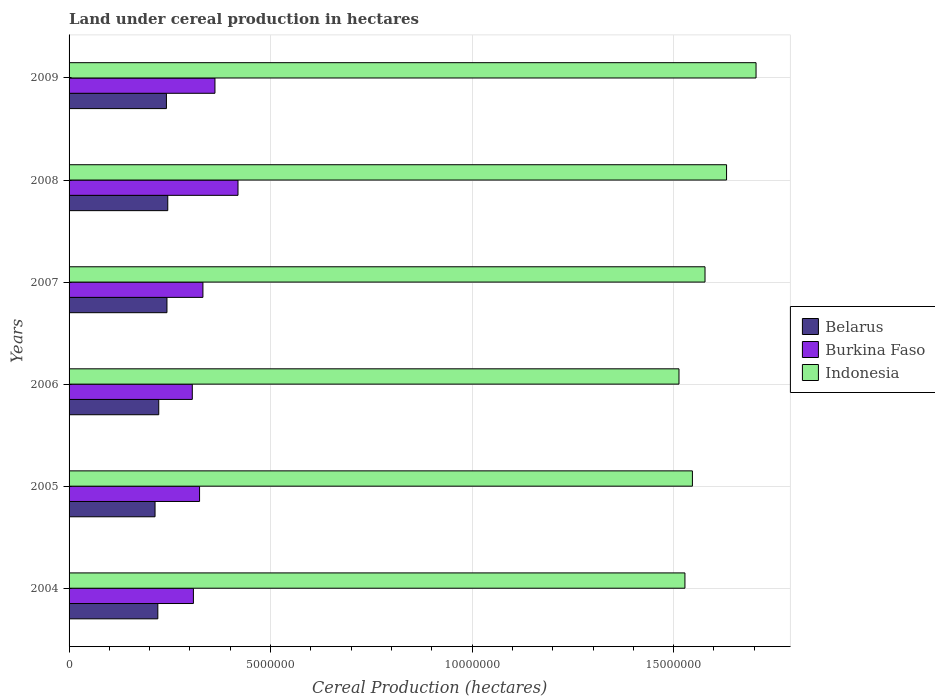How many different coloured bars are there?
Your response must be concise. 3. Are the number of bars per tick equal to the number of legend labels?
Provide a succinct answer. Yes. How many bars are there on the 2nd tick from the bottom?
Provide a succinct answer. 3. In how many cases, is the number of bars for a given year not equal to the number of legend labels?
Keep it short and to the point. 0. What is the land under cereal production in Indonesia in 2004?
Offer a terse response. 1.53e+07. Across all years, what is the maximum land under cereal production in Indonesia?
Offer a terse response. 1.70e+07. Across all years, what is the minimum land under cereal production in Indonesia?
Make the answer very short. 1.51e+07. In which year was the land under cereal production in Indonesia maximum?
Provide a succinct answer. 2009. In which year was the land under cereal production in Belarus minimum?
Offer a terse response. 2005. What is the total land under cereal production in Indonesia in the graph?
Make the answer very short. 9.50e+07. What is the difference between the land under cereal production in Burkina Faso in 2008 and that in 2009?
Provide a short and direct response. 5.72e+05. What is the difference between the land under cereal production in Indonesia in 2009 and the land under cereal production in Burkina Faso in 2007?
Provide a short and direct response. 1.37e+07. What is the average land under cereal production in Indonesia per year?
Keep it short and to the point. 1.58e+07. In the year 2005, what is the difference between the land under cereal production in Burkina Faso and land under cereal production in Indonesia?
Provide a short and direct response. -1.22e+07. In how many years, is the land under cereal production in Burkina Faso greater than 10000000 hectares?
Ensure brevity in your answer.  0. What is the ratio of the land under cereal production in Belarus in 2006 to that in 2007?
Give a very brief answer. 0.92. What is the difference between the highest and the second highest land under cereal production in Belarus?
Offer a very short reply. 2.01e+04. What is the difference between the highest and the lowest land under cereal production in Indonesia?
Your response must be concise. 1.91e+06. In how many years, is the land under cereal production in Indonesia greater than the average land under cereal production in Indonesia taken over all years?
Give a very brief answer. 2. Is the sum of the land under cereal production in Belarus in 2006 and 2007 greater than the maximum land under cereal production in Burkina Faso across all years?
Your answer should be very brief. Yes. What does the 2nd bar from the top in 2007 represents?
Keep it short and to the point. Burkina Faso. What does the 2nd bar from the bottom in 2005 represents?
Your answer should be compact. Burkina Faso. How many bars are there?
Provide a succinct answer. 18. Are the values on the major ticks of X-axis written in scientific E-notation?
Provide a succinct answer. No. Does the graph contain grids?
Provide a short and direct response. Yes. Where does the legend appear in the graph?
Your answer should be very brief. Center right. What is the title of the graph?
Give a very brief answer. Land under cereal production in hectares. What is the label or title of the X-axis?
Provide a succinct answer. Cereal Production (hectares). What is the label or title of the Y-axis?
Make the answer very short. Years. What is the Cereal Production (hectares) in Belarus in 2004?
Keep it short and to the point. 2.20e+06. What is the Cereal Production (hectares) in Burkina Faso in 2004?
Your answer should be very brief. 3.08e+06. What is the Cereal Production (hectares) of Indonesia in 2004?
Keep it short and to the point. 1.53e+07. What is the Cereal Production (hectares) in Belarus in 2005?
Offer a very short reply. 2.13e+06. What is the Cereal Production (hectares) in Burkina Faso in 2005?
Ensure brevity in your answer.  3.24e+06. What is the Cereal Production (hectares) in Indonesia in 2005?
Your response must be concise. 1.55e+07. What is the Cereal Production (hectares) in Belarus in 2006?
Provide a short and direct response. 2.22e+06. What is the Cereal Production (hectares) in Burkina Faso in 2006?
Ensure brevity in your answer.  3.06e+06. What is the Cereal Production (hectares) of Indonesia in 2006?
Your answer should be compact. 1.51e+07. What is the Cereal Production (hectares) of Belarus in 2007?
Your answer should be compact. 2.43e+06. What is the Cereal Production (hectares) in Burkina Faso in 2007?
Offer a terse response. 3.32e+06. What is the Cereal Production (hectares) in Indonesia in 2007?
Ensure brevity in your answer.  1.58e+07. What is the Cereal Production (hectares) in Belarus in 2008?
Give a very brief answer. 2.45e+06. What is the Cereal Production (hectares) of Burkina Faso in 2008?
Your response must be concise. 4.19e+06. What is the Cereal Production (hectares) in Indonesia in 2008?
Your answer should be compact. 1.63e+07. What is the Cereal Production (hectares) of Belarus in 2009?
Provide a short and direct response. 2.42e+06. What is the Cereal Production (hectares) of Burkina Faso in 2009?
Your response must be concise. 3.62e+06. What is the Cereal Production (hectares) in Indonesia in 2009?
Make the answer very short. 1.70e+07. Across all years, what is the maximum Cereal Production (hectares) of Belarus?
Offer a very short reply. 2.45e+06. Across all years, what is the maximum Cereal Production (hectares) in Burkina Faso?
Offer a very short reply. 4.19e+06. Across all years, what is the maximum Cereal Production (hectares) of Indonesia?
Your answer should be very brief. 1.70e+07. Across all years, what is the minimum Cereal Production (hectares) of Belarus?
Provide a succinct answer. 2.13e+06. Across all years, what is the minimum Cereal Production (hectares) in Burkina Faso?
Provide a succinct answer. 3.06e+06. Across all years, what is the minimum Cereal Production (hectares) of Indonesia?
Provide a succinct answer. 1.51e+07. What is the total Cereal Production (hectares) in Belarus in the graph?
Make the answer very short. 1.39e+07. What is the total Cereal Production (hectares) in Burkina Faso in the graph?
Keep it short and to the point. 2.05e+07. What is the total Cereal Production (hectares) of Indonesia in the graph?
Ensure brevity in your answer.  9.50e+07. What is the difference between the Cereal Production (hectares) in Belarus in 2004 and that in 2005?
Give a very brief answer. 6.90e+04. What is the difference between the Cereal Production (hectares) of Burkina Faso in 2004 and that in 2005?
Make the answer very short. -1.53e+05. What is the difference between the Cereal Production (hectares) in Indonesia in 2004 and that in 2005?
Offer a very short reply. -1.85e+05. What is the difference between the Cereal Production (hectares) of Belarus in 2004 and that in 2006?
Your response must be concise. -2.29e+04. What is the difference between the Cereal Production (hectares) in Burkina Faso in 2004 and that in 2006?
Offer a very short reply. 2.76e+04. What is the difference between the Cereal Production (hectares) of Indonesia in 2004 and that in 2006?
Your response must be concise. 1.48e+05. What is the difference between the Cereal Production (hectares) in Belarus in 2004 and that in 2007?
Keep it short and to the point. -2.27e+05. What is the difference between the Cereal Production (hectares) in Burkina Faso in 2004 and that in 2007?
Make the answer very short. -2.36e+05. What is the difference between the Cereal Production (hectares) of Indonesia in 2004 and that in 2007?
Offer a very short reply. -4.98e+05. What is the difference between the Cereal Production (hectares) in Belarus in 2004 and that in 2008?
Offer a terse response. -2.47e+05. What is the difference between the Cereal Production (hectares) in Burkina Faso in 2004 and that in 2008?
Your answer should be very brief. -1.11e+06. What is the difference between the Cereal Production (hectares) of Indonesia in 2004 and that in 2008?
Your answer should be very brief. -1.03e+06. What is the difference between the Cereal Production (hectares) of Belarus in 2004 and that in 2009?
Your answer should be very brief. -2.13e+05. What is the difference between the Cereal Production (hectares) of Burkina Faso in 2004 and that in 2009?
Make the answer very short. -5.34e+05. What is the difference between the Cereal Production (hectares) of Indonesia in 2004 and that in 2009?
Provide a succinct answer. -1.76e+06. What is the difference between the Cereal Production (hectares) of Belarus in 2005 and that in 2006?
Make the answer very short. -9.19e+04. What is the difference between the Cereal Production (hectares) of Burkina Faso in 2005 and that in 2006?
Provide a short and direct response. 1.80e+05. What is the difference between the Cereal Production (hectares) of Indonesia in 2005 and that in 2006?
Provide a succinct answer. 3.33e+05. What is the difference between the Cereal Production (hectares) of Belarus in 2005 and that in 2007?
Give a very brief answer. -2.96e+05. What is the difference between the Cereal Production (hectares) of Burkina Faso in 2005 and that in 2007?
Your response must be concise. -8.34e+04. What is the difference between the Cereal Production (hectares) of Indonesia in 2005 and that in 2007?
Ensure brevity in your answer.  -3.13e+05. What is the difference between the Cereal Production (hectares) in Belarus in 2005 and that in 2008?
Your response must be concise. -3.16e+05. What is the difference between the Cereal Production (hectares) of Burkina Faso in 2005 and that in 2008?
Your response must be concise. -9.54e+05. What is the difference between the Cereal Production (hectares) in Indonesia in 2005 and that in 2008?
Your answer should be very brief. -8.47e+05. What is the difference between the Cereal Production (hectares) in Belarus in 2005 and that in 2009?
Ensure brevity in your answer.  -2.83e+05. What is the difference between the Cereal Production (hectares) of Burkina Faso in 2005 and that in 2009?
Make the answer very short. -3.82e+05. What is the difference between the Cereal Production (hectares) of Indonesia in 2005 and that in 2009?
Your response must be concise. -1.58e+06. What is the difference between the Cereal Production (hectares) of Belarus in 2006 and that in 2007?
Ensure brevity in your answer.  -2.04e+05. What is the difference between the Cereal Production (hectares) in Burkina Faso in 2006 and that in 2007?
Provide a succinct answer. -2.64e+05. What is the difference between the Cereal Production (hectares) of Indonesia in 2006 and that in 2007?
Your answer should be very brief. -6.46e+05. What is the difference between the Cereal Production (hectares) in Belarus in 2006 and that in 2008?
Offer a very short reply. -2.24e+05. What is the difference between the Cereal Production (hectares) of Burkina Faso in 2006 and that in 2008?
Offer a very short reply. -1.13e+06. What is the difference between the Cereal Production (hectares) in Indonesia in 2006 and that in 2008?
Your response must be concise. -1.18e+06. What is the difference between the Cereal Production (hectares) of Belarus in 2006 and that in 2009?
Make the answer very short. -1.91e+05. What is the difference between the Cereal Production (hectares) in Burkina Faso in 2006 and that in 2009?
Your answer should be compact. -5.62e+05. What is the difference between the Cereal Production (hectares) of Indonesia in 2006 and that in 2009?
Keep it short and to the point. -1.91e+06. What is the difference between the Cereal Production (hectares) in Belarus in 2007 and that in 2008?
Offer a terse response. -2.01e+04. What is the difference between the Cereal Production (hectares) in Burkina Faso in 2007 and that in 2008?
Your response must be concise. -8.70e+05. What is the difference between the Cereal Production (hectares) in Indonesia in 2007 and that in 2008?
Offer a very short reply. -5.35e+05. What is the difference between the Cereal Production (hectares) in Belarus in 2007 and that in 2009?
Keep it short and to the point. 1.32e+04. What is the difference between the Cereal Production (hectares) in Burkina Faso in 2007 and that in 2009?
Your answer should be very brief. -2.98e+05. What is the difference between the Cereal Production (hectares) of Indonesia in 2007 and that in 2009?
Offer a very short reply. -1.27e+06. What is the difference between the Cereal Production (hectares) of Belarus in 2008 and that in 2009?
Your answer should be very brief. 3.33e+04. What is the difference between the Cereal Production (hectares) of Burkina Faso in 2008 and that in 2009?
Make the answer very short. 5.72e+05. What is the difference between the Cereal Production (hectares) in Indonesia in 2008 and that in 2009?
Ensure brevity in your answer.  -7.32e+05. What is the difference between the Cereal Production (hectares) of Belarus in 2004 and the Cereal Production (hectares) of Burkina Faso in 2005?
Ensure brevity in your answer.  -1.04e+06. What is the difference between the Cereal Production (hectares) in Belarus in 2004 and the Cereal Production (hectares) in Indonesia in 2005?
Offer a terse response. -1.33e+07. What is the difference between the Cereal Production (hectares) of Burkina Faso in 2004 and the Cereal Production (hectares) of Indonesia in 2005?
Offer a very short reply. -1.24e+07. What is the difference between the Cereal Production (hectares) of Belarus in 2004 and the Cereal Production (hectares) of Burkina Faso in 2006?
Your response must be concise. -8.55e+05. What is the difference between the Cereal Production (hectares) of Belarus in 2004 and the Cereal Production (hectares) of Indonesia in 2006?
Keep it short and to the point. -1.29e+07. What is the difference between the Cereal Production (hectares) in Burkina Faso in 2004 and the Cereal Production (hectares) in Indonesia in 2006?
Offer a very short reply. -1.20e+07. What is the difference between the Cereal Production (hectares) in Belarus in 2004 and the Cereal Production (hectares) in Burkina Faso in 2007?
Your response must be concise. -1.12e+06. What is the difference between the Cereal Production (hectares) of Belarus in 2004 and the Cereal Production (hectares) of Indonesia in 2007?
Your response must be concise. -1.36e+07. What is the difference between the Cereal Production (hectares) in Burkina Faso in 2004 and the Cereal Production (hectares) in Indonesia in 2007?
Give a very brief answer. -1.27e+07. What is the difference between the Cereal Production (hectares) in Belarus in 2004 and the Cereal Production (hectares) in Burkina Faso in 2008?
Offer a terse response. -1.99e+06. What is the difference between the Cereal Production (hectares) of Belarus in 2004 and the Cereal Production (hectares) of Indonesia in 2008?
Give a very brief answer. -1.41e+07. What is the difference between the Cereal Production (hectares) of Burkina Faso in 2004 and the Cereal Production (hectares) of Indonesia in 2008?
Your answer should be very brief. -1.32e+07. What is the difference between the Cereal Production (hectares) in Belarus in 2004 and the Cereal Production (hectares) in Burkina Faso in 2009?
Provide a succinct answer. -1.42e+06. What is the difference between the Cereal Production (hectares) of Belarus in 2004 and the Cereal Production (hectares) of Indonesia in 2009?
Your response must be concise. -1.48e+07. What is the difference between the Cereal Production (hectares) in Burkina Faso in 2004 and the Cereal Production (hectares) in Indonesia in 2009?
Offer a very short reply. -1.40e+07. What is the difference between the Cereal Production (hectares) of Belarus in 2005 and the Cereal Production (hectares) of Burkina Faso in 2006?
Make the answer very short. -9.24e+05. What is the difference between the Cereal Production (hectares) of Belarus in 2005 and the Cereal Production (hectares) of Indonesia in 2006?
Ensure brevity in your answer.  -1.30e+07. What is the difference between the Cereal Production (hectares) of Burkina Faso in 2005 and the Cereal Production (hectares) of Indonesia in 2006?
Make the answer very short. -1.19e+07. What is the difference between the Cereal Production (hectares) in Belarus in 2005 and the Cereal Production (hectares) in Burkina Faso in 2007?
Make the answer very short. -1.19e+06. What is the difference between the Cereal Production (hectares) of Belarus in 2005 and the Cereal Production (hectares) of Indonesia in 2007?
Keep it short and to the point. -1.36e+07. What is the difference between the Cereal Production (hectares) in Burkina Faso in 2005 and the Cereal Production (hectares) in Indonesia in 2007?
Your answer should be very brief. -1.25e+07. What is the difference between the Cereal Production (hectares) of Belarus in 2005 and the Cereal Production (hectares) of Burkina Faso in 2008?
Your answer should be compact. -2.06e+06. What is the difference between the Cereal Production (hectares) in Belarus in 2005 and the Cereal Production (hectares) in Indonesia in 2008?
Provide a succinct answer. -1.42e+07. What is the difference between the Cereal Production (hectares) of Burkina Faso in 2005 and the Cereal Production (hectares) of Indonesia in 2008?
Keep it short and to the point. -1.31e+07. What is the difference between the Cereal Production (hectares) in Belarus in 2005 and the Cereal Production (hectares) in Burkina Faso in 2009?
Your answer should be very brief. -1.49e+06. What is the difference between the Cereal Production (hectares) in Belarus in 2005 and the Cereal Production (hectares) in Indonesia in 2009?
Offer a terse response. -1.49e+07. What is the difference between the Cereal Production (hectares) in Burkina Faso in 2005 and the Cereal Production (hectares) in Indonesia in 2009?
Offer a very short reply. -1.38e+07. What is the difference between the Cereal Production (hectares) of Belarus in 2006 and the Cereal Production (hectares) of Burkina Faso in 2007?
Offer a terse response. -1.10e+06. What is the difference between the Cereal Production (hectares) in Belarus in 2006 and the Cereal Production (hectares) in Indonesia in 2007?
Your answer should be very brief. -1.36e+07. What is the difference between the Cereal Production (hectares) in Burkina Faso in 2006 and the Cereal Production (hectares) in Indonesia in 2007?
Ensure brevity in your answer.  -1.27e+07. What is the difference between the Cereal Production (hectares) in Belarus in 2006 and the Cereal Production (hectares) in Burkina Faso in 2008?
Keep it short and to the point. -1.97e+06. What is the difference between the Cereal Production (hectares) in Belarus in 2006 and the Cereal Production (hectares) in Indonesia in 2008?
Offer a very short reply. -1.41e+07. What is the difference between the Cereal Production (hectares) in Burkina Faso in 2006 and the Cereal Production (hectares) in Indonesia in 2008?
Provide a short and direct response. -1.33e+07. What is the difference between the Cereal Production (hectares) in Belarus in 2006 and the Cereal Production (hectares) in Burkina Faso in 2009?
Offer a terse response. -1.39e+06. What is the difference between the Cereal Production (hectares) in Belarus in 2006 and the Cereal Production (hectares) in Indonesia in 2009?
Provide a succinct answer. -1.48e+07. What is the difference between the Cereal Production (hectares) of Burkina Faso in 2006 and the Cereal Production (hectares) of Indonesia in 2009?
Ensure brevity in your answer.  -1.40e+07. What is the difference between the Cereal Production (hectares) in Belarus in 2007 and the Cereal Production (hectares) in Burkina Faso in 2008?
Offer a terse response. -1.76e+06. What is the difference between the Cereal Production (hectares) of Belarus in 2007 and the Cereal Production (hectares) of Indonesia in 2008?
Ensure brevity in your answer.  -1.39e+07. What is the difference between the Cereal Production (hectares) in Burkina Faso in 2007 and the Cereal Production (hectares) in Indonesia in 2008?
Your answer should be very brief. -1.30e+07. What is the difference between the Cereal Production (hectares) of Belarus in 2007 and the Cereal Production (hectares) of Burkina Faso in 2009?
Provide a succinct answer. -1.19e+06. What is the difference between the Cereal Production (hectares) in Belarus in 2007 and the Cereal Production (hectares) in Indonesia in 2009?
Provide a short and direct response. -1.46e+07. What is the difference between the Cereal Production (hectares) of Burkina Faso in 2007 and the Cereal Production (hectares) of Indonesia in 2009?
Offer a very short reply. -1.37e+07. What is the difference between the Cereal Production (hectares) in Belarus in 2008 and the Cereal Production (hectares) in Burkina Faso in 2009?
Offer a very short reply. -1.17e+06. What is the difference between the Cereal Production (hectares) in Belarus in 2008 and the Cereal Production (hectares) in Indonesia in 2009?
Give a very brief answer. -1.46e+07. What is the difference between the Cereal Production (hectares) of Burkina Faso in 2008 and the Cereal Production (hectares) of Indonesia in 2009?
Your response must be concise. -1.29e+07. What is the average Cereal Production (hectares) in Belarus per year?
Keep it short and to the point. 2.31e+06. What is the average Cereal Production (hectares) of Burkina Faso per year?
Provide a short and direct response. 3.42e+06. What is the average Cereal Production (hectares) in Indonesia per year?
Ensure brevity in your answer.  1.58e+07. In the year 2004, what is the difference between the Cereal Production (hectares) in Belarus and Cereal Production (hectares) in Burkina Faso?
Offer a terse response. -8.83e+05. In the year 2004, what is the difference between the Cereal Production (hectares) of Belarus and Cereal Production (hectares) of Indonesia?
Ensure brevity in your answer.  -1.31e+07. In the year 2004, what is the difference between the Cereal Production (hectares) in Burkina Faso and Cereal Production (hectares) in Indonesia?
Keep it short and to the point. -1.22e+07. In the year 2005, what is the difference between the Cereal Production (hectares) in Belarus and Cereal Production (hectares) in Burkina Faso?
Your answer should be compact. -1.10e+06. In the year 2005, what is the difference between the Cereal Production (hectares) of Belarus and Cereal Production (hectares) of Indonesia?
Offer a terse response. -1.33e+07. In the year 2005, what is the difference between the Cereal Production (hectares) of Burkina Faso and Cereal Production (hectares) of Indonesia?
Ensure brevity in your answer.  -1.22e+07. In the year 2006, what is the difference between the Cereal Production (hectares) of Belarus and Cereal Production (hectares) of Burkina Faso?
Your answer should be compact. -8.32e+05. In the year 2006, what is the difference between the Cereal Production (hectares) in Belarus and Cereal Production (hectares) in Indonesia?
Offer a very short reply. -1.29e+07. In the year 2006, what is the difference between the Cereal Production (hectares) of Burkina Faso and Cereal Production (hectares) of Indonesia?
Provide a succinct answer. -1.21e+07. In the year 2007, what is the difference between the Cereal Production (hectares) of Belarus and Cereal Production (hectares) of Burkina Faso?
Your answer should be very brief. -8.92e+05. In the year 2007, what is the difference between the Cereal Production (hectares) in Belarus and Cereal Production (hectares) in Indonesia?
Keep it short and to the point. -1.33e+07. In the year 2007, what is the difference between the Cereal Production (hectares) of Burkina Faso and Cereal Production (hectares) of Indonesia?
Your answer should be very brief. -1.25e+07. In the year 2008, what is the difference between the Cereal Production (hectares) in Belarus and Cereal Production (hectares) in Burkina Faso?
Your answer should be very brief. -1.74e+06. In the year 2008, what is the difference between the Cereal Production (hectares) in Belarus and Cereal Production (hectares) in Indonesia?
Offer a terse response. -1.39e+07. In the year 2008, what is the difference between the Cereal Production (hectares) in Burkina Faso and Cereal Production (hectares) in Indonesia?
Ensure brevity in your answer.  -1.21e+07. In the year 2009, what is the difference between the Cereal Production (hectares) of Belarus and Cereal Production (hectares) of Burkina Faso?
Ensure brevity in your answer.  -1.20e+06. In the year 2009, what is the difference between the Cereal Production (hectares) in Belarus and Cereal Production (hectares) in Indonesia?
Keep it short and to the point. -1.46e+07. In the year 2009, what is the difference between the Cereal Production (hectares) of Burkina Faso and Cereal Production (hectares) of Indonesia?
Your answer should be very brief. -1.34e+07. What is the ratio of the Cereal Production (hectares) in Belarus in 2004 to that in 2005?
Provide a succinct answer. 1.03. What is the ratio of the Cereal Production (hectares) of Burkina Faso in 2004 to that in 2005?
Make the answer very short. 0.95. What is the ratio of the Cereal Production (hectares) in Indonesia in 2004 to that in 2005?
Give a very brief answer. 0.99. What is the ratio of the Cereal Production (hectares) in Belarus in 2004 to that in 2006?
Provide a short and direct response. 0.99. What is the ratio of the Cereal Production (hectares) in Indonesia in 2004 to that in 2006?
Offer a very short reply. 1.01. What is the ratio of the Cereal Production (hectares) in Belarus in 2004 to that in 2007?
Offer a terse response. 0.91. What is the ratio of the Cereal Production (hectares) in Burkina Faso in 2004 to that in 2007?
Your answer should be very brief. 0.93. What is the ratio of the Cereal Production (hectares) in Indonesia in 2004 to that in 2007?
Provide a short and direct response. 0.97. What is the ratio of the Cereal Production (hectares) of Belarus in 2004 to that in 2008?
Your answer should be compact. 0.9. What is the ratio of the Cereal Production (hectares) of Burkina Faso in 2004 to that in 2008?
Ensure brevity in your answer.  0.74. What is the ratio of the Cereal Production (hectares) of Indonesia in 2004 to that in 2008?
Provide a succinct answer. 0.94. What is the ratio of the Cereal Production (hectares) in Belarus in 2004 to that in 2009?
Provide a short and direct response. 0.91. What is the ratio of the Cereal Production (hectares) in Burkina Faso in 2004 to that in 2009?
Your response must be concise. 0.85. What is the ratio of the Cereal Production (hectares) in Indonesia in 2004 to that in 2009?
Your response must be concise. 0.9. What is the ratio of the Cereal Production (hectares) of Belarus in 2005 to that in 2006?
Give a very brief answer. 0.96. What is the ratio of the Cereal Production (hectares) of Burkina Faso in 2005 to that in 2006?
Provide a short and direct response. 1.06. What is the ratio of the Cereal Production (hectares) of Belarus in 2005 to that in 2007?
Keep it short and to the point. 0.88. What is the ratio of the Cereal Production (hectares) of Burkina Faso in 2005 to that in 2007?
Offer a terse response. 0.97. What is the ratio of the Cereal Production (hectares) of Indonesia in 2005 to that in 2007?
Give a very brief answer. 0.98. What is the ratio of the Cereal Production (hectares) of Belarus in 2005 to that in 2008?
Ensure brevity in your answer.  0.87. What is the ratio of the Cereal Production (hectares) in Burkina Faso in 2005 to that in 2008?
Offer a very short reply. 0.77. What is the ratio of the Cereal Production (hectares) in Indonesia in 2005 to that in 2008?
Offer a very short reply. 0.95. What is the ratio of the Cereal Production (hectares) in Belarus in 2005 to that in 2009?
Your response must be concise. 0.88. What is the ratio of the Cereal Production (hectares) of Burkina Faso in 2005 to that in 2009?
Offer a very short reply. 0.89. What is the ratio of the Cereal Production (hectares) in Indonesia in 2005 to that in 2009?
Offer a terse response. 0.91. What is the ratio of the Cereal Production (hectares) in Belarus in 2006 to that in 2007?
Offer a very short reply. 0.92. What is the ratio of the Cereal Production (hectares) of Burkina Faso in 2006 to that in 2007?
Provide a succinct answer. 0.92. What is the ratio of the Cereal Production (hectares) of Indonesia in 2006 to that in 2007?
Provide a succinct answer. 0.96. What is the ratio of the Cereal Production (hectares) of Belarus in 2006 to that in 2008?
Make the answer very short. 0.91. What is the ratio of the Cereal Production (hectares) in Burkina Faso in 2006 to that in 2008?
Offer a terse response. 0.73. What is the ratio of the Cereal Production (hectares) of Indonesia in 2006 to that in 2008?
Provide a succinct answer. 0.93. What is the ratio of the Cereal Production (hectares) in Belarus in 2006 to that in 2009?
Provide a succinct answer. 0.92. What is the ratio of the Cereal Production (hectares) of Burkina Faso in 2006 to that in 2009?
Your answer should be very brief. 0.84. What is the ratio of the Cereal Production (hectares) in Indonesia in 2006 to that in 2009?
Make the answer very short. 0.89. What is the ratio of the Cereal Production (hectares) in Burkina Faso in 2007 to that in 2008?
Make the answer very short. 0.79. What is the ratio of the Cereal Production (hectares) in Indonesia in 2007 to that in 2008?
Your response must be concise. 0.97. What is the ratio of the Cereal Production (hectares) of Belarus in 2007 to that in 2009?
Provide a succinct answer. 1.01. What is the ratio of the Cereal Production (hectares) in Burkina Faso in 2007 to that in 2009?
Your answer should be very brief. 0.92. What is the ratio of the Cereal Production (hectares) in Indonesia in 2007 to that in 2009?
Keep it short and to the point. 0.93. What is the ratio of the Cereal Production (hectares) of Belarus in 2008 to that in 2009?
Ensure brevity in your answer.  1.01. What is the ratio of the Cereal Production (hectares) of Burkina Faso in 2008 to that in 2009?
Ensure brevity in your answer.  1.16. What is the ratio of the Cereal Production (hectares) of Indonesia in 2008 to that in 2009?
Offer a very short reply. 0.96. What is the difference between the highest and the second highest Cereal Production (hectares) in Belarus?
Offer a terse response. 2.01e+04. What is the difference between the highest and the second highest Cereal Production (hectares) of Burkina Faso?
Make the answer very short. 5.72e+05. What is the difference between the highest and the second highest Cereal Production (hectares) in Indonesia?
Provide a short and direct response. 7.32e+05. What is the difference between the highest and the lowest Cereal Production (hectares) in Belarus?
Provide a short and direct response. 3.16e+05. What is the difference between the highest and the lowest Cereal Production (hectares) of Burkina Faso?
Your answer should be compact. 1.13e+06. What is the difference between the highest and the lowest Cereal Production (hectares) of Indonesia?
Keep it short and to the point. 1.91e+06. 